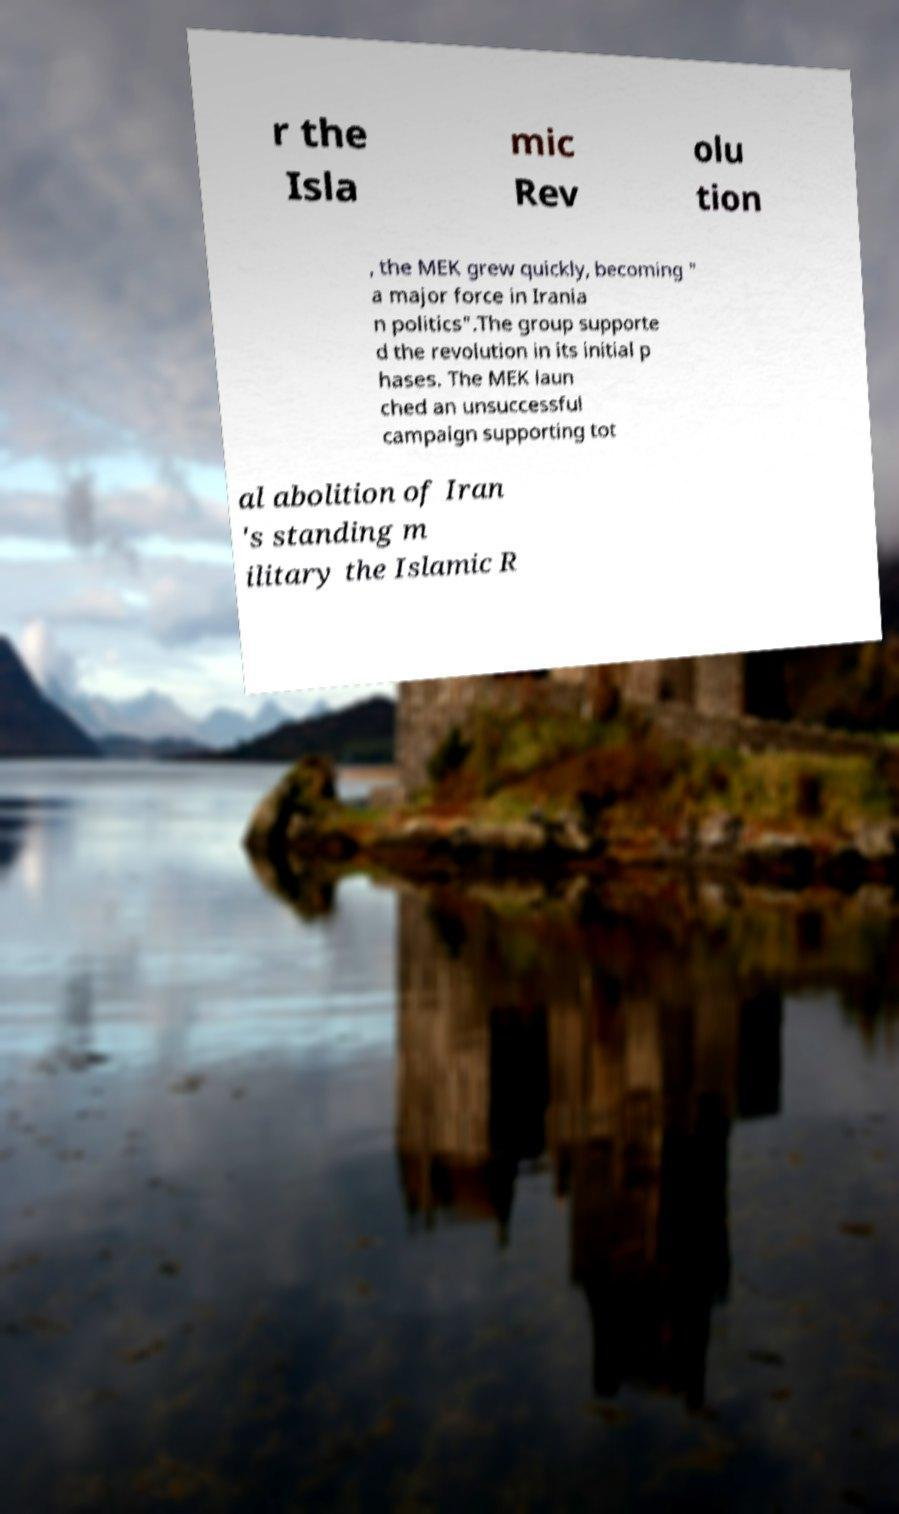Could you extract and type out the text from this image? r the Isla mic Rev olu tion , the MEK grew quickly, becoming " a major force in Irania n politics".The group supporte d the revolution in its initial p hases. The MEK laun ched an unsuccessful campaign supporting tot al abolition of Iran 's standing m ilitary the Islamic R 